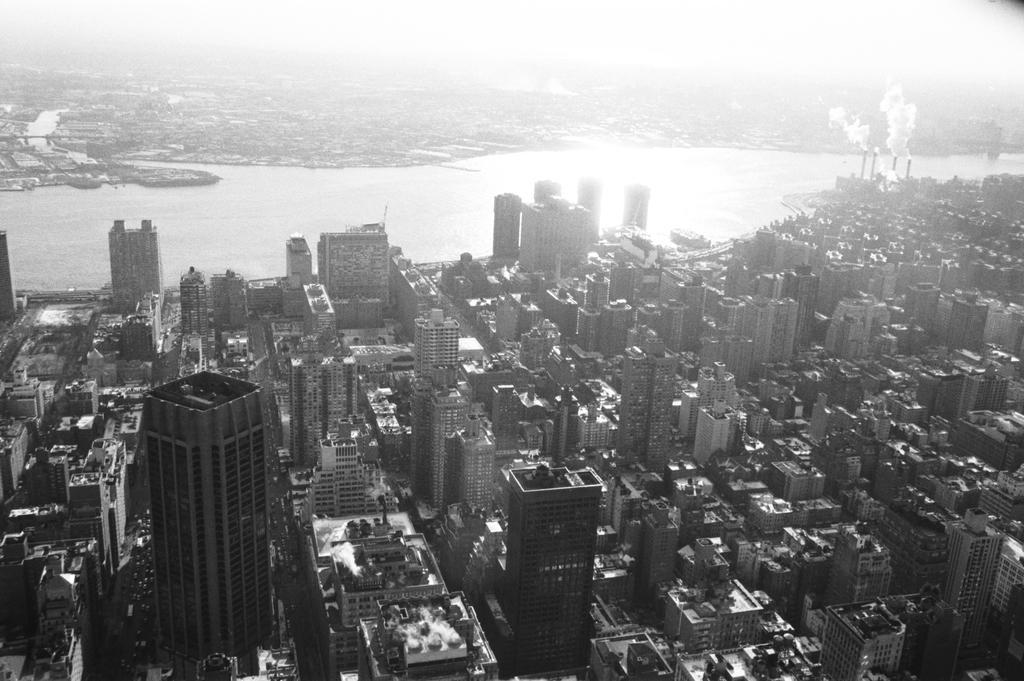What type of structures can be seen in the image? There are buildings in the image. What natural element is visible in the image? There is water visible in the image. What else can be seen in the image besides buildings and water? There is smoke in the image. How many chickens are swimming in the water in the image? There are no chickens present in the image; it features buildings, water, and smoke. What type of root can be seen growing near the buildings in the image? There is no root visible in the image; it only shows buildings, water, and smoke. 